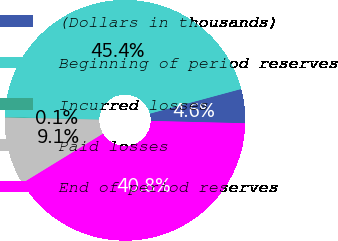Convert chart. <chart><loc_0><loc_0><loc_500><loc_500><pie_chart><fcel>(Dollars in thousands)<fcel>Beginning of period reserves<fcel>Incurred losses<fcel>Paid losses<fcel>End of period reserves<nl><fcel>4.59%<fcel>45.38%<fcel>0.06%<fcel>9.12%<fcel>40.85%<nl></chart> 